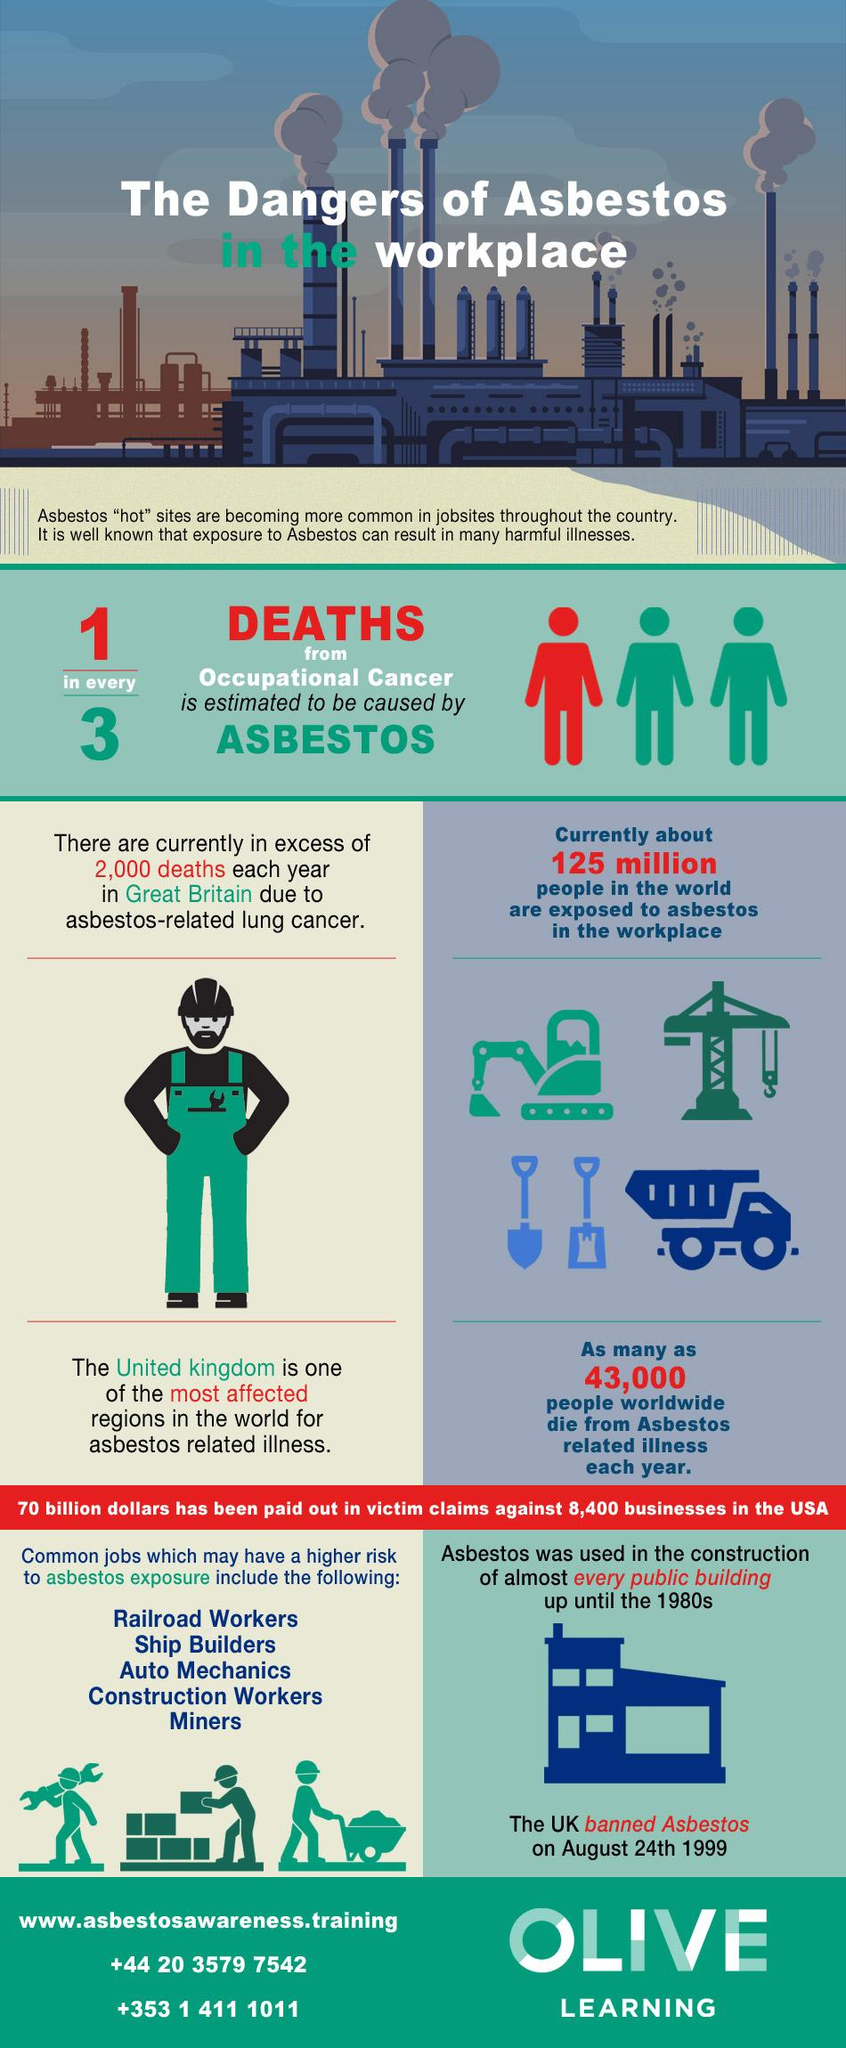Give some essential details in this illustration. In the first graphic after the heading, the text inside the quotation marks reads "hot. Railroad workers, ship builders, and auto mechanics are at a higher risk of asbestos exposure compared to minors and construction workers. Asbestos is known to cause lung cancer, which is a type of cancer that originates in the lungs. The number "43000" is written in red. According to studies, asbestos is responsible for approximately 33.3% of deaths caused by occupational cancer. 